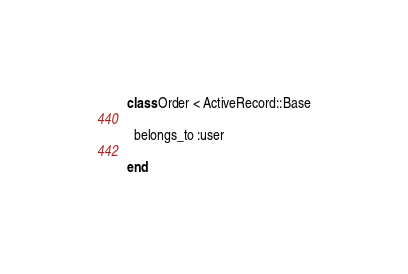<code> <loc_0><loc_0><loc_500><loc_500><_Ruby_>class Order < ActiveRecord::Base

  belongs_to :user

end
</code> 